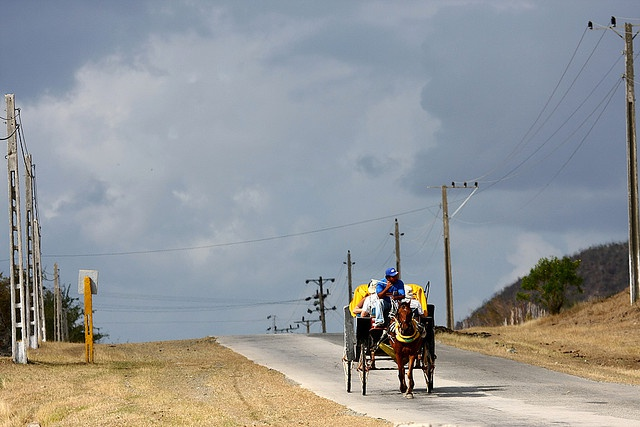Describe the objects in this image and their specific colors. I can see horse in gray, black, maroon, ivory, and brown tones, people in gray, black, navy, maroon, and darkgray tones, and people in gray, white, darkgray, maroon, and tan tones in this image. 